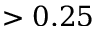<formula> <loc_0><loc_0><loc_500><loc_500>> 0 . 2 5</formula> 